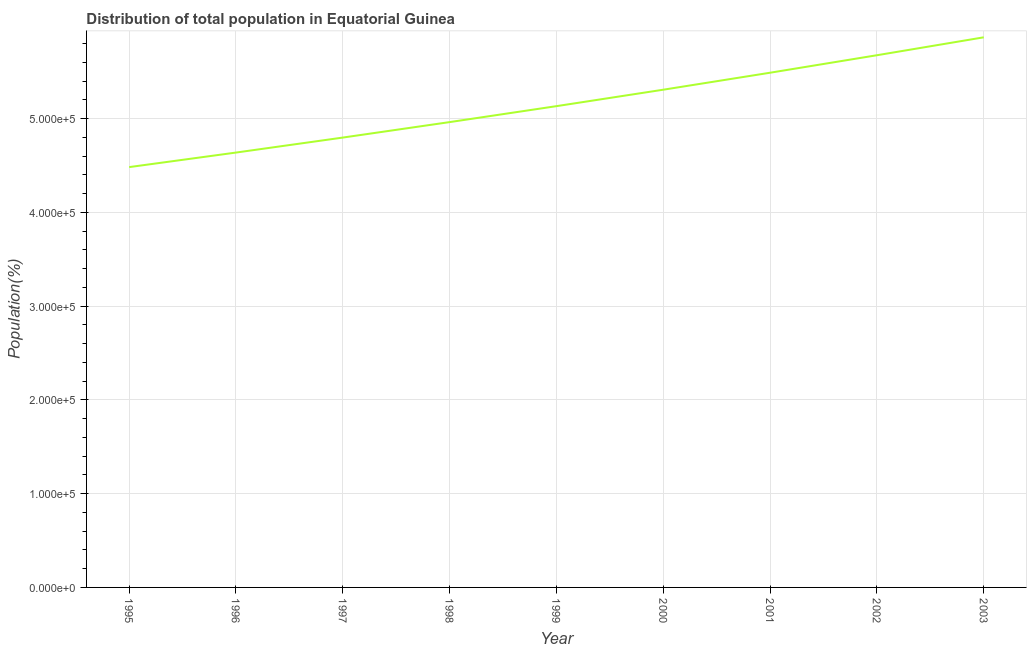What is the population in 1999?
Your answer should be compact. 5.13e+05. Across all years, what is the maximum population?
Offer a terse response. 5.87e+05. Across all years, what is the minimum population?
Give a very brief answer. 4.48e+05. In which year was the population maximum?
Keep it short and to the point. 2003. What is the sum of the population?
Make the answer very short. 4.64e+06. What is the difference between the population in 1999 and 2002?
Ensure brevity in your answer.  -5.43e+04. What is the average population per year?
Your answer should be very brief. 5.15e+05. What is the median population?
Your answer should be very brief. 5.13e+05. In how many years, is the population greater than 160000 %?
Provide a succinct answer. 9. Do a majority of the years between 2001 and 2003 (inclusive) have population greater than 360000 %?
Ensure brevity in your answer.  Yes. What is the ratio of the population in 1995 to that in 1996?
Your answer should be compact. 0.97. Is the difference between the population in 1997 and 2003 greater than the difference between any two years?
Provide a succinct answer. No. What is the difference between the highest and the second highest population?
Give a very brief answer. 1.91e+04. Is the sum of the population in 1998 and 2000 greater than the maximum population across all years?
Offer a terse response. Yes. What is the difference between the highest and the lowest population?
Your answer should be compact. 1.38e+05. In how many years, is the population greater than the average population taken over all years?
Make the answer very short. 4. Does the population monotonically increase over the years?
Offer a terse response. Yes. Are the values on the major ticks of Y-axis written in scientific E-notation?
Ensure brevity in your answer.  Yes. Does the graph contain any zero values?
Ensure brevity in your answer.  No. What is the title of the graph?
Your answer should be very brief. Distribution of total population in Equatorial Guinea . What is the label or title of the X-axis?
Your answer should be compact. Year. What is the label or title of the Y-axis?
Make the answer very short. Population(%). What is the Population(%) of 1995?
Make the answer very short. 4.48e+05. What is the Population(%) in 1996?
Provide a short and direct response. 4.64e+05. What is the Population(%) of 1997?
Offer a terse response. 4.80e+05. What is the Population(%) of 1998?
Keep it short and to the point. 4.96e+05. What is the Population(%) in 1999?
Keep it short and to the point. 5.13e+05. What is the Population(%) of 2000?
Offer a very short reply. 5.31e+05. What is the Population(%) in 2001?
Your answer should be very brief. 5.49e+05. What is the Population(%) of 2002?
Ensure brevity in your answer.  5.68e+05. What is the Population(%) in 2003?
Your response must be concise. 5.87e+05. What is the difference between the Population(%) in 1995 and 1996?
Offer a terse response. -1.55e+04. What is the difference between the Population(%) in 1995 and 1997?
Provide a succinct answer. -3.15e+04. What is the difference between the Population(%) in 1995 and 1998?
Offer a terse response. -4.80e+04. What is the difference between the Population(%) in 1995 and 1999?
Keep it short and to the point. -6.50e+04. What is the difference between the Population(%) in 1995 and 2000?
Your answer should be compact. -8.26e+04. What is the difference between the Population(%) in 1995 and 2001?
Make the answer very short. -1.01e+05. What is the difference between the Population(%) in 1995 and 2002?
Offer a very short reply. -1.19e+05. What is the difference between the Population(%) in 1995 and 2003?
Your answer should be compact. -1.38e+05. What is the difference between the Population(%) in 1996 and 1997?
Keep it short and to the point. -1.60e+04. What is the difference between the Population(%) in 1996 and 1998?
Offer a terse response. -3.25e+04. What is the difference between the Population(%) in 1996 and 1999?
Your answer should be very brief. -4.95e+04. What is the difference between the Population(%) in 1996 and 2000?
Offer a very short reply. -6.71e+04. What is the difference between the Population(%) in 1996 and 2001?
Keep it short and to the point. -8.52e+04. What is the difference between the Population(%) in 1996 and 2002?
Your answer should be very brief. -1.04e+05. What is the difference between the Population(%) in 1996 and 2003?
Give a very brief answer. -1.23e+05. What is the difference between the Population(%) in 1997 and 1998?
Your response must be concise. -1.65e+04. What is the difference between the Population(%) in 1997 and 1999?
Provide a succinct answer. -3.35e+04. What is the difference between the Population(%) in 1997 and 2000?
Make the answer very short. -5.11e+04. What is the difference between the Population(%) in 1997 and 2001?
Provide a succinct answer. -6.92e+04. What is the difference between the Population(%) in 1997 and 2002?
Keep it short and to the point. -8.78e+04. What is the difference between the Population(%) in 1997 and 2003?
Provide a short and direct response. -1.07e+05. What is the difference between the Population(%) in 1998 and 1999?
Provide a short and direct response. -1.70e+04. What is the difference between the Population(%) in 1998 and 2000?
Offer a terse response. -3.46e+04. What is the difference between the Population(%) in 1998 and 2001?
Give a very brief answer. -5.27e+04. What is the difference between the Population(%) in 1998 and 2002?
Your response must be concise. -7.13e+04. What is the difference between the Population(%) in 1998 and 2003?
Your answer should be compact. -9.04e+04. What is the difference between the Population(%) in 1999 and 2000?
Your answer should be compact. -1.75e+04. What is the difference between the Population(%) in 1999 and 2001?
Your answer should be very brief. -3.57e+04. What is the difference between the Population(%) in 1999 and 2002?
Ensure brevity in your answer.  -5.43e+04. What is the difference between the Population(%) in 1999 and 2003?
Provide a short and direct response. -7.34e+04. What is the difference between the Population(%) in 2000 and 2001?
Your answer should be compact. -1.81e+04. What is the difference between the Population(%) in 2000 and 2002?
Give a very brief answer. -3.68e+04. What is the difference between the Population(%) in 2000 and 2003?
Give a very brief answer. -5.59e+04. What is the difference between the Population(%) in 2001 and 2002?
Make the answer very short. -1.87e+04. What is the difference between the Population(%) in 2001 and 2003?
Your answer should be compact. -3.78e+04. What is the difference between the Population(%) in 2002 and 2003?
Provide a succinct answer. -1.91e+04. What is the ratio of the Population(%) in 1995 to that in 1997?
Your answer should be very brief. 0.93. What is the ratio of the Population(%) in 1995 to that in 1998?
Provide a succinct answer. 0.9. What is the ratio of the Population(%) in 1995 to that in 1999?
Provide a succinct answer. 0.87. What is the ratio of the Population(%) in 1995 to that in 2000?
Provide a succinct answer. 0.84. What is the ratio of the Population(%) in 1995 to that in 2001?
Provide a succinct answer. 0.82. What is the ratio of the Population(%) in 1995 to that in 2002?
Your answer should be compact. 0.79. What is the ratio of the Population(%) in 1995 to that in 2003?
Keep it short and to the point. 0.76. What is the ratio of the Population(%) in 1996 to that in 1997?
Your answer should be compact. 0.97. What is the ratio of the Population(%) in 1996 to that in 1998?
Give a very brief answer. 0.94. What is the ratio of the Population(%) in 1996 to that in 1999?
Your response must be concise. 0.9. What is the ratio of the Population(%) in 1996 to that in 2000?
Your answer should be very brief. 0.87. What is the ratio of the Population(%) in 1996 to that in 2001?
Provide a succinct answer. 0.84. What is the ratio of the Population(%) in 1996 to that in 2002?
Your answer should be compact. 0.82. What is the ratio of the Population(%) in 1996 to that in 2003?
Give a very brief answer. 0.79. What is the ratio of the Population(%) in 1997 to that in 1998?
Ensure brevity in your answer.  0.97. What is the ratio of the Population(%) in 1997 to that in 1999?
Provide a succinct answer. 0.94. What is the ratio of the Population(%) in 1997 to that in 2000?
Ensure brevity in your answer.  0.9. What is the ratio of the Population(%) in 1997 to that in 2001?
Your answer should be compact. 0.87. What is the ratio of the Population(%) in 1997 to that in 2002?
Your answer should be compact. 0.84. What is the ratio of the Population(%) in 1997 to that in 2003?
Keep it short and to the point. 0.82. What is the ratio of the Population(%) in 1998 to that in 2000?
Provide a short and direct response. 0.94. What is the ratio of the Population(%) in 1998 to that in 2001?
Make the answer very short. 0.9. What is the ratio of the Population(%) in 1998 to that in 2002?
Give a very brief answer. 0.87. What is the ratio of the Population(%) in 1998 to that in 2003?
Your response must be concise. 0.85. What is the ratio of the Population(%) in 1999 to that in 2001?
Offer a very short reply. 0.94. What is the ratio of the Population(%) in 1999 to that in 2002?
Keep it short and to the point. 0.9. What is the ratio of the Population(%) in 1999 to that in 2003?
Provide a succinct answer. 0.88. What is the ratio of the Population(%) in 2000 to that in 2002?
Give a very brief answer. 0.94. What is the ratio of the Population(%) in 2000 to that in 2003?
Keep it short and to the point. 0.91. What is the ratio of the Population(%) in 2001 to that in 2002?
Keep it short and to the point. 0.97. What is the ratio of the Population(%) in 2001 to that in 2003?
Ensure brevity in your answer.  0.94. What is the ratio of the Population(%) in 2002 to that in 2003?
Make the answer very short. 0.97. 